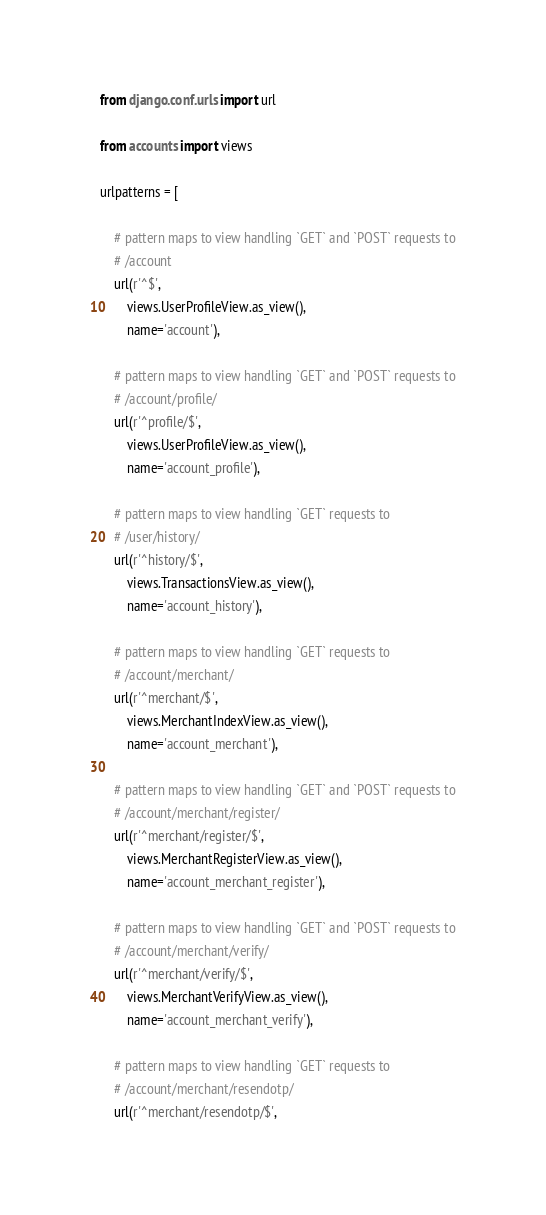<code> <loc_0><loc_0><loc_500><loc_500><_Python_>from django.conf.urls import url

from accounts import views

urlpatterns = [

    # pattern maps to view handling `GET` and `POST` requests to
    # /account
    url(r'^$',
        views.UserProfileView.as_view(),
        name='account'),

    # pattern maps to view handling `GET` and `POST` requests to
    # /account/profile/
    url(r'^profile/$',
        views.UserProfileView.as_view(),
        name='account_profile'),

    # pattern maps to view handling `GET` requests to
    # /user/history/
    url(r'^history/$',
        views.TransactionsView.as_view(),
        name='account_history'),

    # pattern maps to view handling `GET` requests to
    # /account/merchant/
    url(r'^merchant/$',
        views.MerchantIndexView.as_view(),
        name='account_merchant'),

    # pattern maps to view handling `GET` and `POST` requests to
    # /account/merchant/register/
    url(r'^merchant/register/$',
        views.MerchantRegisterView.as_view(),
        name='account_merchant_register'),

    # pattern maps to view handling `GET` and `POST` requests to
    # /account/merchant/verify/
    url(r'^merchant/verify/$',
        views.MerchantVerifyView.as_view(),
        name='account_merchant_verify'),

    # pattern maps to view handling `GET` requests to
    # /account/merchant/resendotp/
    url(r'^merchant/resendotp/$',</code> 